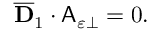Convert formula to latex. <formula><loc_0><loc_0><loc_500><loc_500>\begin{array} { r } { \overline { D } _ { 1 } \cdot A _ { \varepsilon \perp } = 0 . } \end{array}</formula> 